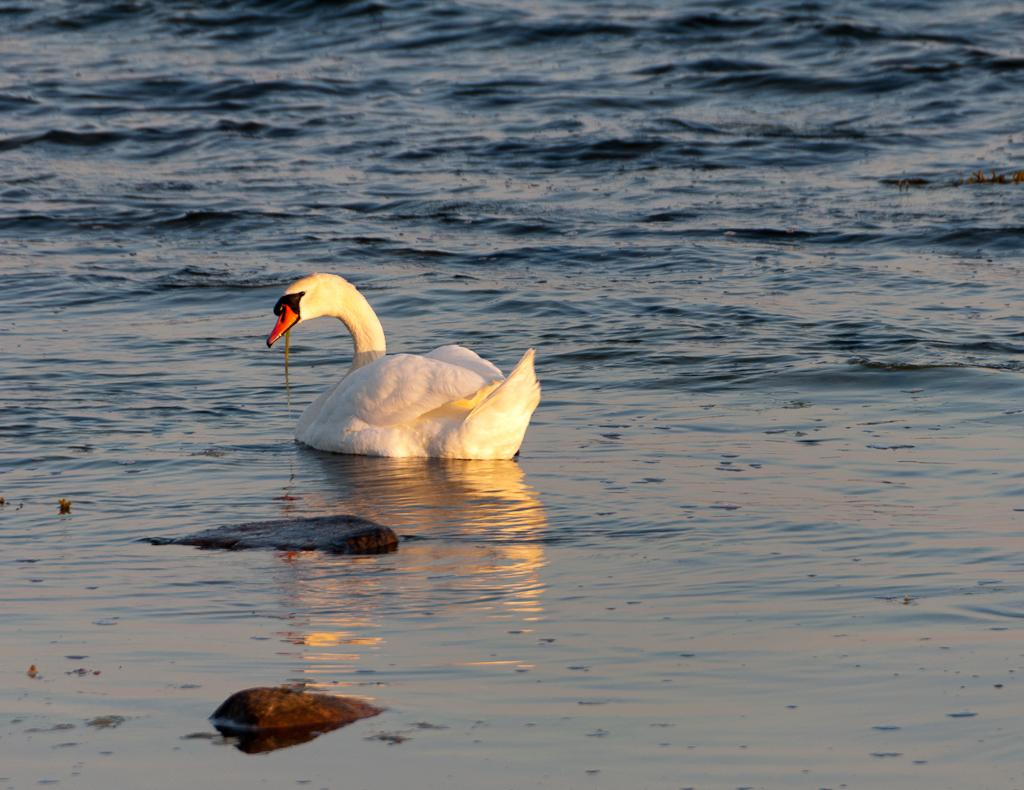What is the main subject in the center of the image? There is a swan in the center of the image. What type of environment is depicted in the image? There is water visible in the image. What else can be seen in the image besides the swan and water? There are stones in the image. What type of profit can be seen in the image? There is no profit visible in the image; it features a swan in water with stones. Can you tell me how many rats are present in the image? There are no rats present in the image; it features a swan in water with stones. 